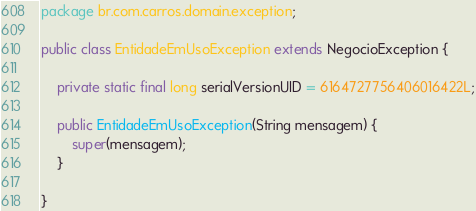Convert code to text. <code><loc_0><loc_0><loc_500><loc_500><_Java_>package br.com.carros.domain.exception;

public class EntidadeEmUsoException extends NegocioException {

	private static final long serialVersionUID = 6164727756406016422L;

	public EntidadeEmUsoException(String mensagem) {
		super(mensagem);						
	}
	
}
</code> 